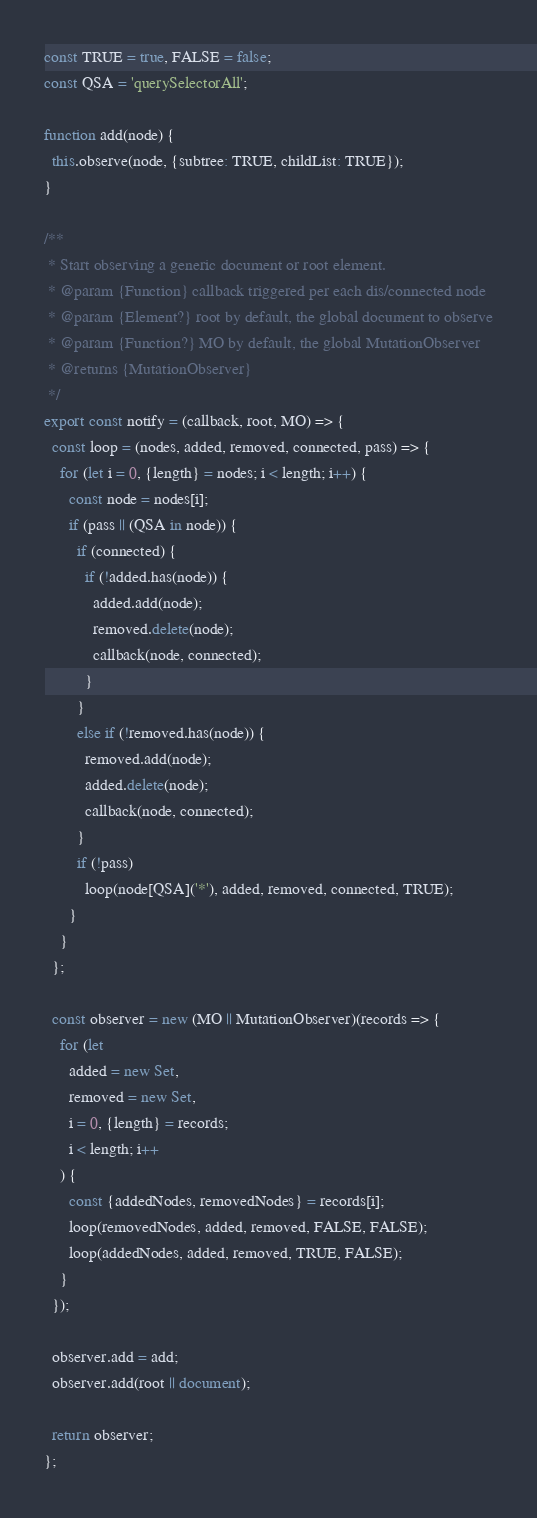<code> <loc_0><loc_0><loc_500><loc_500><_JavaScript_>const TRUE = true, FALSE = false;
const QSA = 'querySelectorAll';

function add(node) {
  this.observe(node, {subtree: TRUE, childList: TRUE});
}

/**
 * Start observing a generic document or root element.
 * @param {Function} callback triggered per each dis/connected node
 * @param {Element?} root by default, the global document to observe
 * @param {Function?} MO by default, the global MutationObserver
 * @returns {MutationObserver}
 */
export const notify = (callback, root, MO) => {
  const loop = (nodes, added, removed, connected, pass) => {
    for (let i = 0, {length} = nodes; i < length; i++) {
      const node = nodes[i];
      if (pass || (QSA in node)) {
        if (connected) {
          if (!added.has(node)) {
            added.add(node);
            removed.delete(node);
            callback(node, connected);
          }
        }
        else if (!removed.has(node)) {
          removed.add(node);
          added.delete(node);
          callback(node, connected);
        }
        if (!pass)
          loop(node[QSA]('*'), added, removed, connected, TRUE);
      }
    }
  };

  const observer = new (MO || MutationObserver)(records => {
    for (let
      added = new Set,
      removed = new Set,
      i = 0, {length} = records;
      i < length; i++
    ) {
      const {addedNodes, removedNodes} = records[i];
      loop(removedNodes, added, removed, FALSE, FALSE);
      loop(addedNodes, added, removed, TRUE, FALSE);
    }
  });

  observer.add = add;
  observer.add(root || document);

  return observer;
};
</code> 